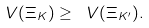Convert formula to latex. <formula><loc_0><loc_0><loc_500><loc_500>\ V ( \Xi _ { K } ) \geq \ V ( \Xi _ { K ^ { \prime } } ) .</formula> 